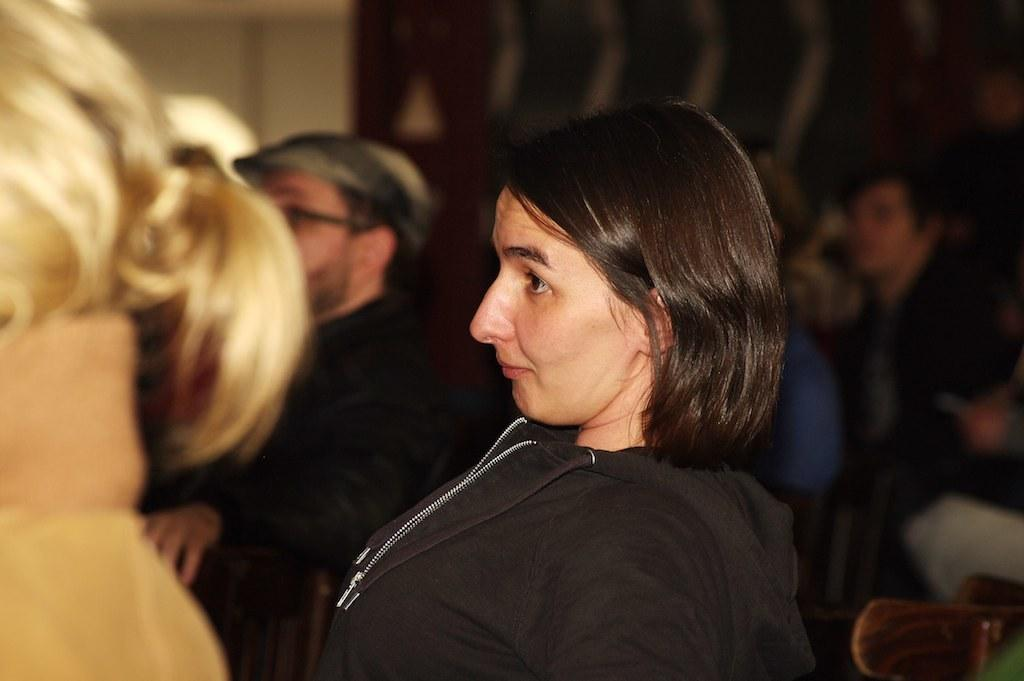What is the main subject of the image? There is a woman in the image. Are there any other people in the image besides the woman? Yes, there are people present in the image. Can you describe any background elements in the image? There may be a wall in the image. What type of music is the woman learning to play in the image? There is no indication in the image that the woman is learning to play any music, so it cannot be determined from the picture. 